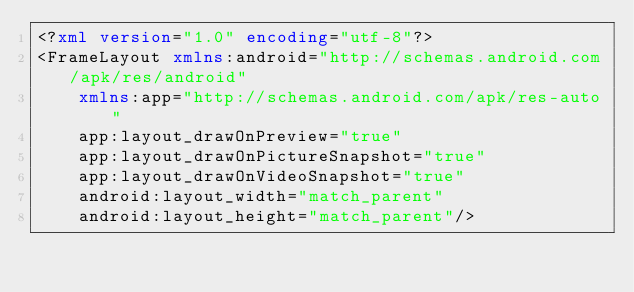<code> <loc_0><loc_0><loc_500><loc_500><_XML_><?xml version="1.0" encoding="utf-8"?>
<FrameLayout xmlns:android="http://schemas.android.com/apk/res/android"
    xmlns:app="http://schemas.android.com/apk/res-auto"
    app:layout_drawOnPreview="true"
    app:layout_drawOnPictureSnapshot="true"
    app:layout_drawOnVideoSnapshot="true"
    android:layout_width="match_parent"
    android:layout_height="match_parent"/></code> 